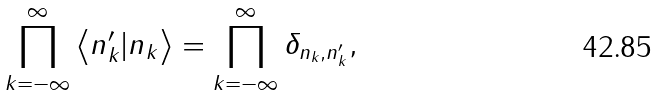Convert formula to latex. <formula><loc_0><loc_0><loc_500><loc_500>\prod _ { k = - \infty } ^ { \infty } \left \langle n ^ { \prime } _ { k } | n _ { k } \right \rangle = \prod _ { k = - \infty } ^ { \infty } \delta _ { n _ { k } , n ^ { \prime } _ { k } } ,</formula> 